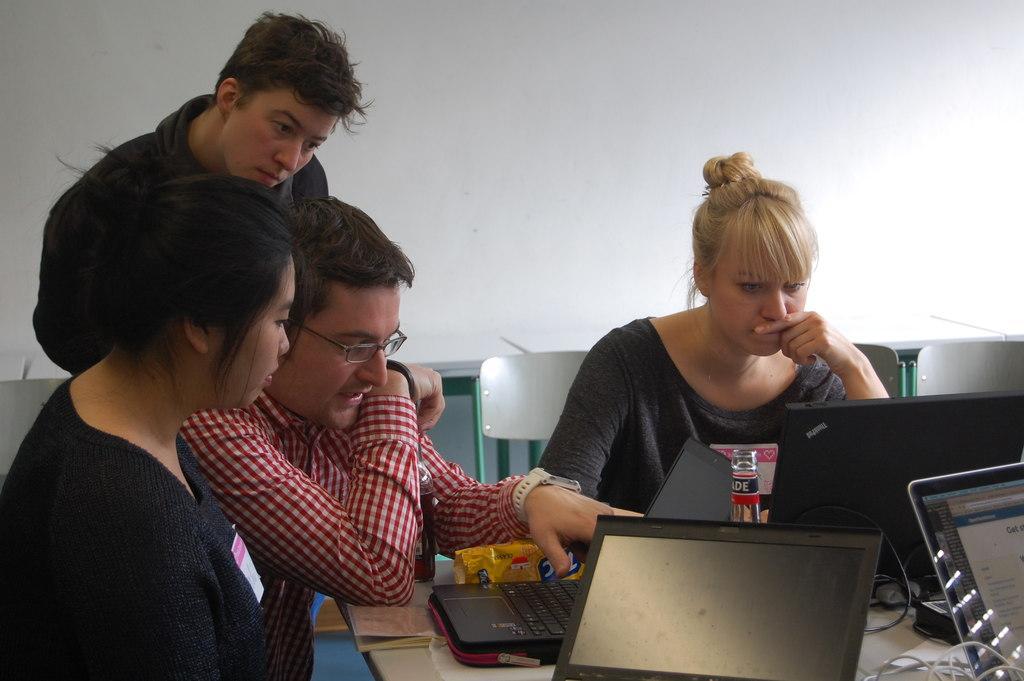Can you describe this image briefly? In the picture we can see three people are sitting on a chairs near the table, and one person standing and looking on the table on the table we can see a laptop's on which they are working, in the background there is a white wall, persons who are sitting on a table are explaining something in the laptop. 